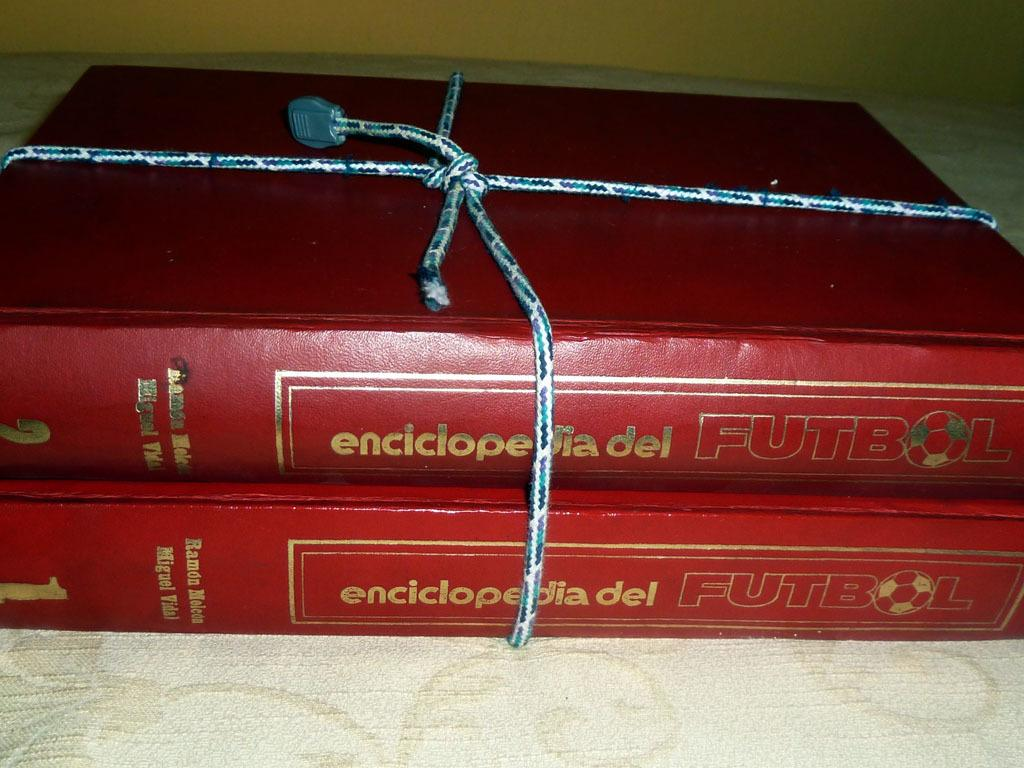What objects are on the table in the image? There are books on the table in the image. What can be seen in the background of the image? There is a wall in the background of the image. How many toys can be seen falling into the hole in the image? There is no hole or toys present in the image. 